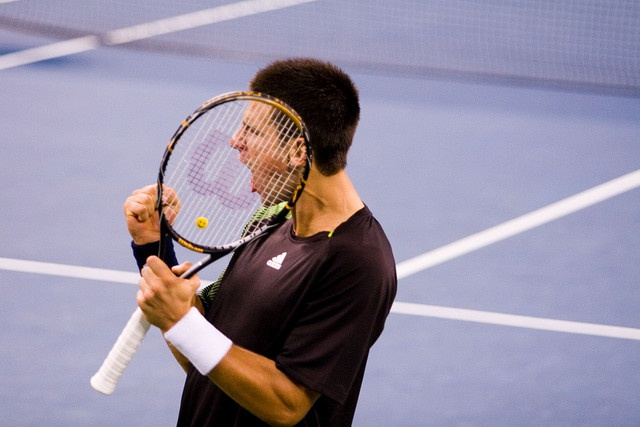Describe the objects in this image and their specific colors. I can see people in lightgray, black, maroon, brown, and tan tones and tennis racket in lightgray, darkgray, lavender, and black tones in this image. 